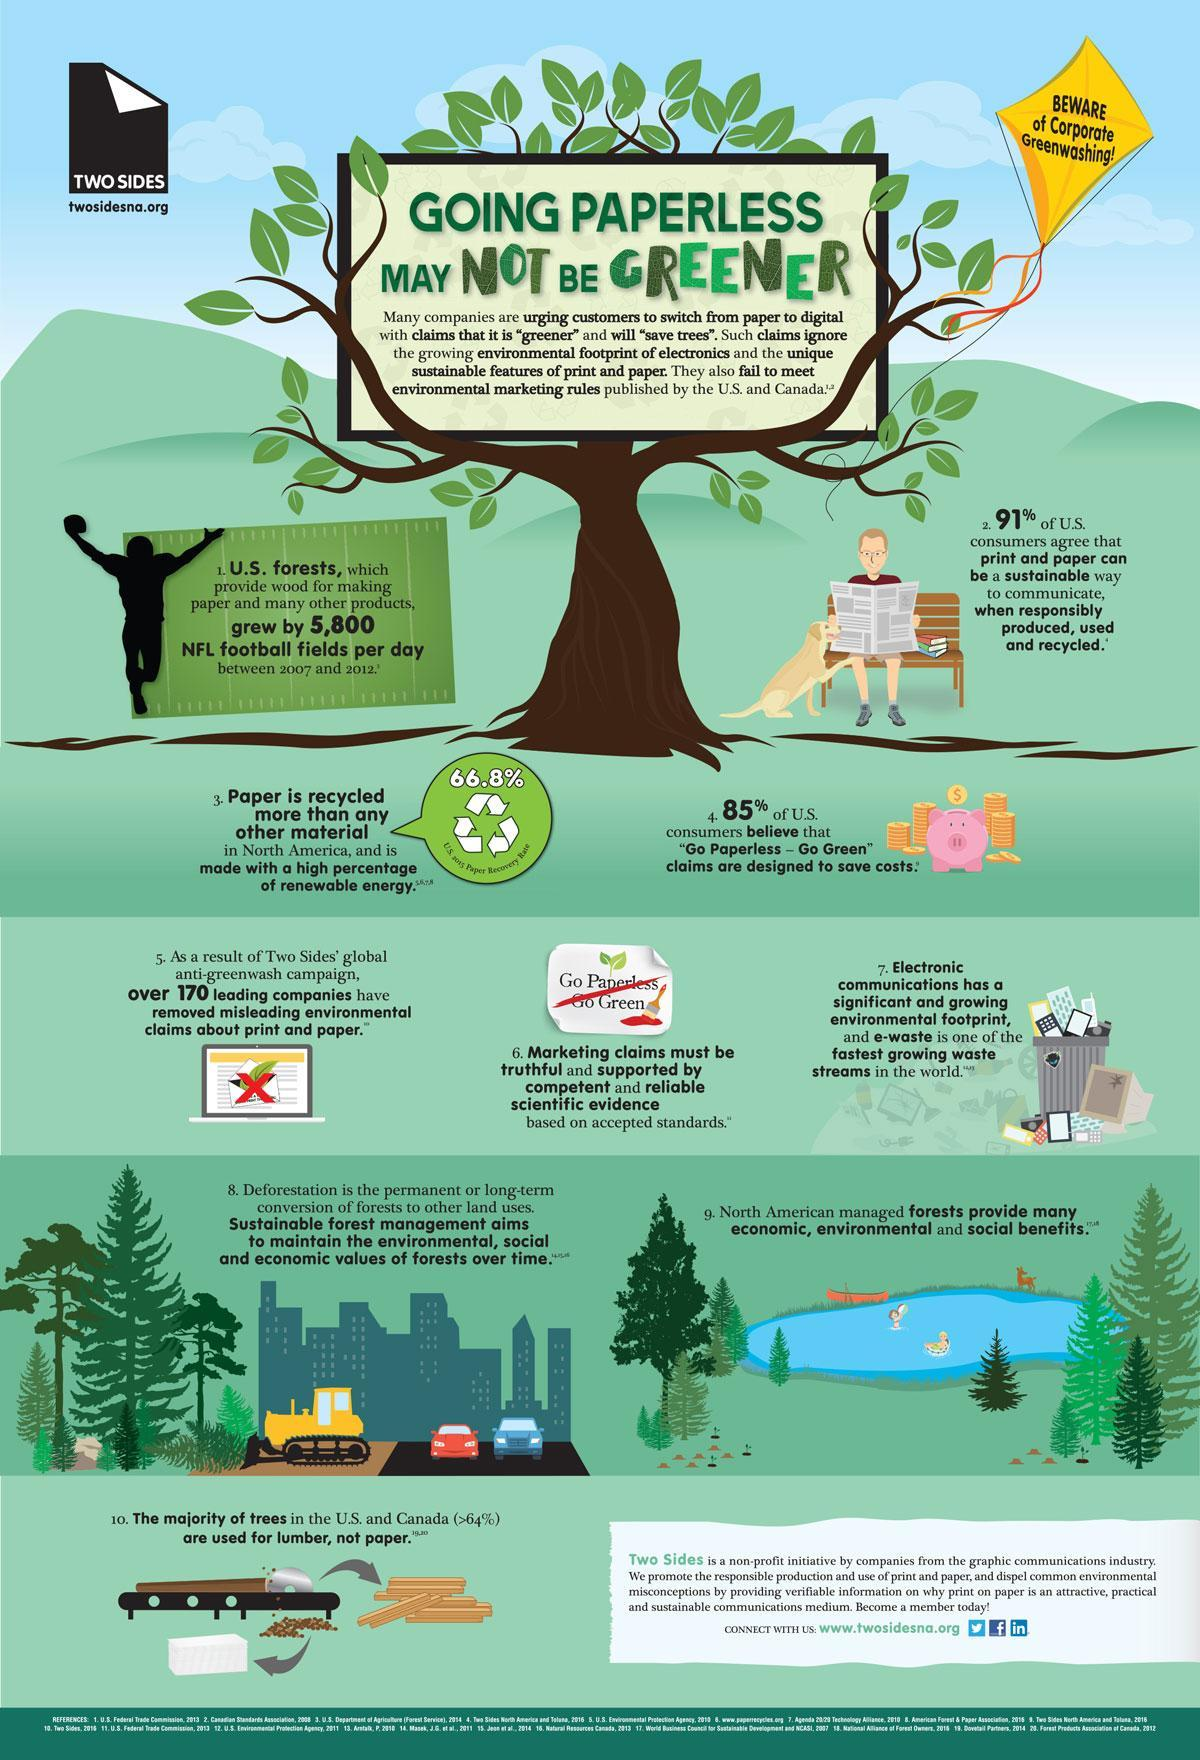What percentage of U.S. consumers do not believe that 'Go Paperless - Go Green' claims are designed to save costs?
Answer the question with a short phrase. 15% What is the paper recovery rate in the U.S. in 2015? 66.8% What percentage of U.S. consumers don't agree that print & paper can be a sustainable way to communicate when responsibly produced, used & recycled? 9% 